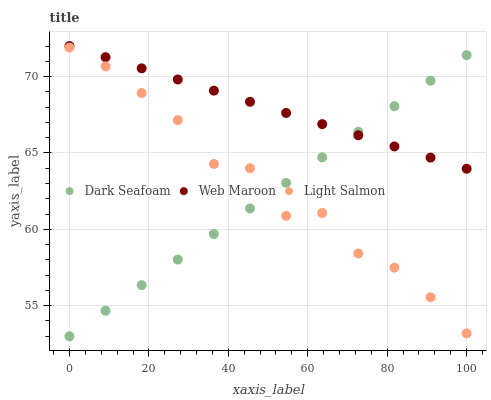Does Dark Seafoam have the minimum area under the curve?
Answer yes or no. Yes. Does Web Maroon have the maximum area under the curve?
Answer yes or no. Yes. Does Light Salmon have the minimum area under the curve?
Answer yes or no. No. Does Light Salmon have the maximum area under the curve?
Answer yes or no. No. Is Dark Seafoam the smoothest?
Answer yes or no. Yes. Is Light Salmon the roughest?
Answer yes or no. Yes. Is Web Maroon the smoothest?
Answer yes or no. No. Is Web Maroon the roughest?
Answer yes or no. No. Does Dark Seafoam have the lowest value?
Answer yes or no. Yes. Does Light Salmon have the lowest value?
Answer yes or no. No. Does Web Maroon have the highest value?
Answer yes or no. Yes. Does Light Salmon have the highest value?
Answer yes or no. No. Is Light Salmon less than Web Maroon?
Answer yes or no. Yes. Is Web Maroon greater than Light Salmon?
Answer yes or no. Yes. Does Dark Seafoam intersect Web Maroon?
Answer yes or no. Yes. Is Dark Seafoam less than Web Maroon?
Answer yes or no. No. Is Dark Seafoam greater than Web Maroon?
Answer yes or no. No. Does Light Salmon intersect Web Maroon?
Answer yes or no. No. 